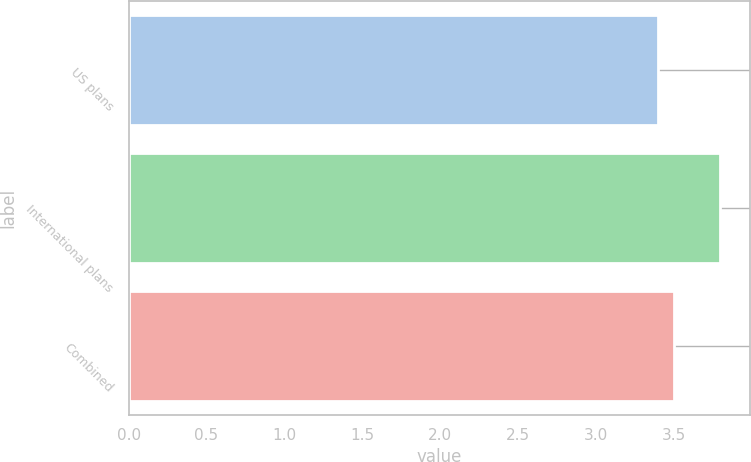<chart> <loc_0><loc_0><loc_500><loc_500><bar_chart><fcel>US plans<fcel>International plans<fcel>Combined<nl><fcel>3.4<fcel>3.8<fcel>3.5<nl></chart> 